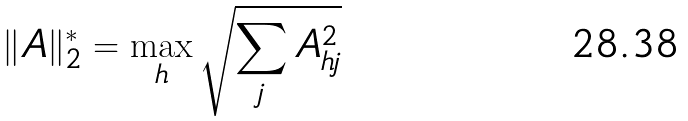Convert formula to latex. <formula><loc_0><loc_0><loc_500><loc_500>\| A \| _ { 2 } ^ { * } & = \max _ { h } \sqrt { \sum _ { j } { A _ { h j } ^ { 2 } } }</formula> 